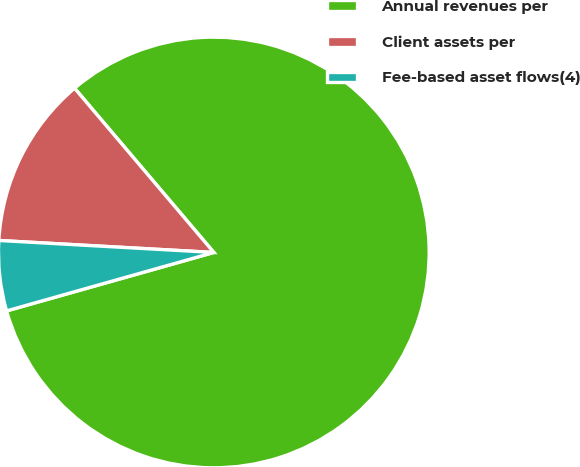Convert chart. <chart><loc_0><loc_0><loc_500><loc_500><pie_chart><fcel>Annual revenues per<fcel>Client assets per<fcel>Fee-based asset flows(4)<nl><fcel>81.82%<fcel>12.92%<fcel>5.26%<nl></chart> 